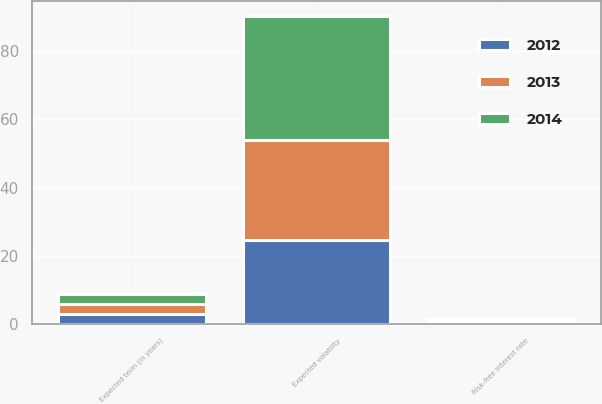Convert chart to OTSL. <chart><loc_0><loc_0><loc_500><loc_500><stacked_bar_chart><ecel><fcel>Expected volatility<fcel>Risk-free interest rate<fcel>Expected term (in years)<nl><fcel>2012<fcel>24.77<fcel>0.8<fcel>3<nl><fcel>2013<fcel>29.18<fcel>0.42<fcel>3<nl><fcel>2014<fcel>36.3<fcel>0.42<fcel>3<nl></chart> 